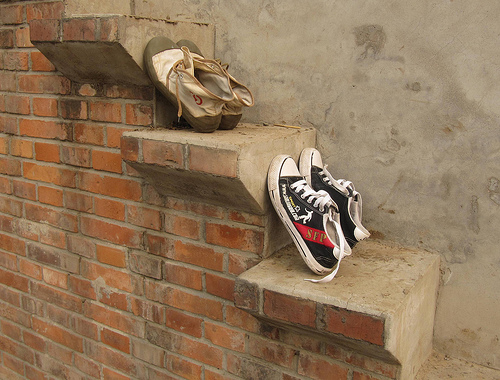<image>
Can you confirm if the stairs is to the right of the wall? No. The stairs is not to the right of the wall. The horizontal positioning shows a different relationship. Is the shoes above the brick? No. The shoes is not positioned above the brick. The vertical arrangement shows a different relationship. 